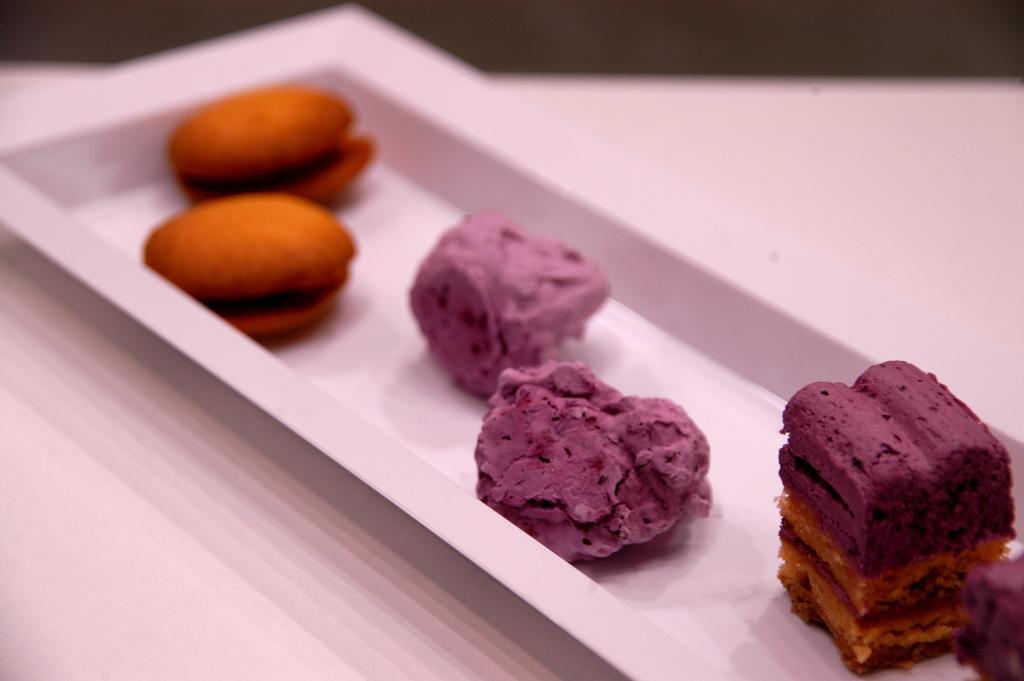In one or two sentences, can you explain what this image depicts? In this image there is a table, on that table there is a plate, in that place there is a food item. 